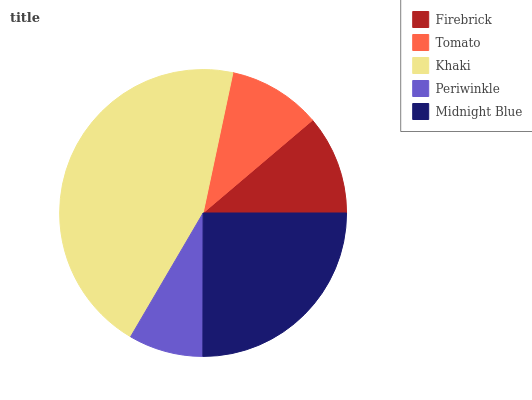Is Periwinkle the minimum?
Answer yes or no. Yes. Is Khaki the maximum?
Answer yes or no. Yes. Is Tomato the minimum?
Answer yes or no. No. Is Tomato the maximum?
Answer yes or no. No. Is Firebrick greater than Tomato?
Answer yes or no. Yes. Is Tomato less than Firebrick?
Answer yes or no. Yes. Is Tomato greater than Firebrick?
Answer yes or no. No. Is Firebrick less than Tomato?
Answer yes or no. No. Is Firebrick the high median?
Answer yes or no. Yes. Is Firebrick the low median?
Answer yes or no. Yes. Is Periwinkle the high median?
Answer yes or no. No. Is Tomato the low median?
Answer yes or no. No. 